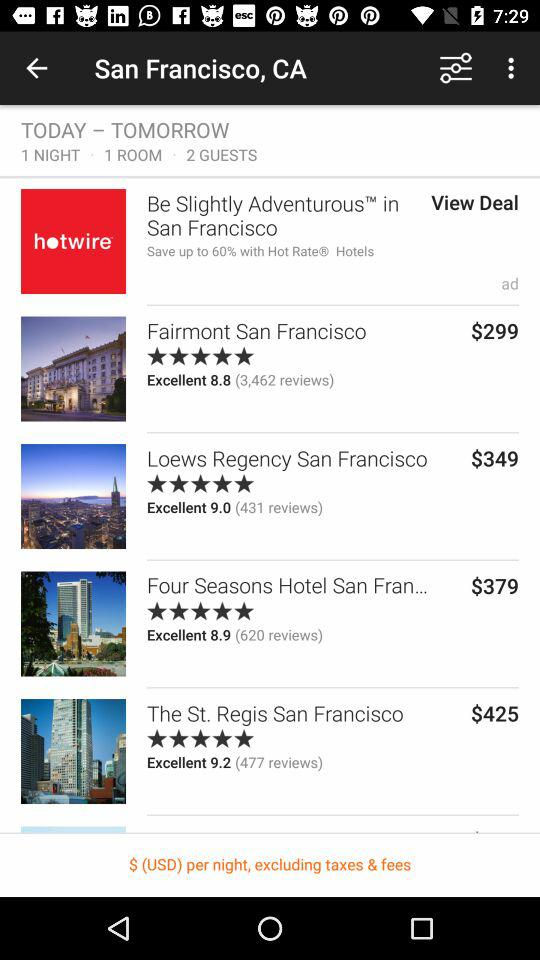How many people have given reviews for the St. Regis San Francisco Hotel? There are 477 people who have given reviews for the St. Regis San Francisco Hotel. 